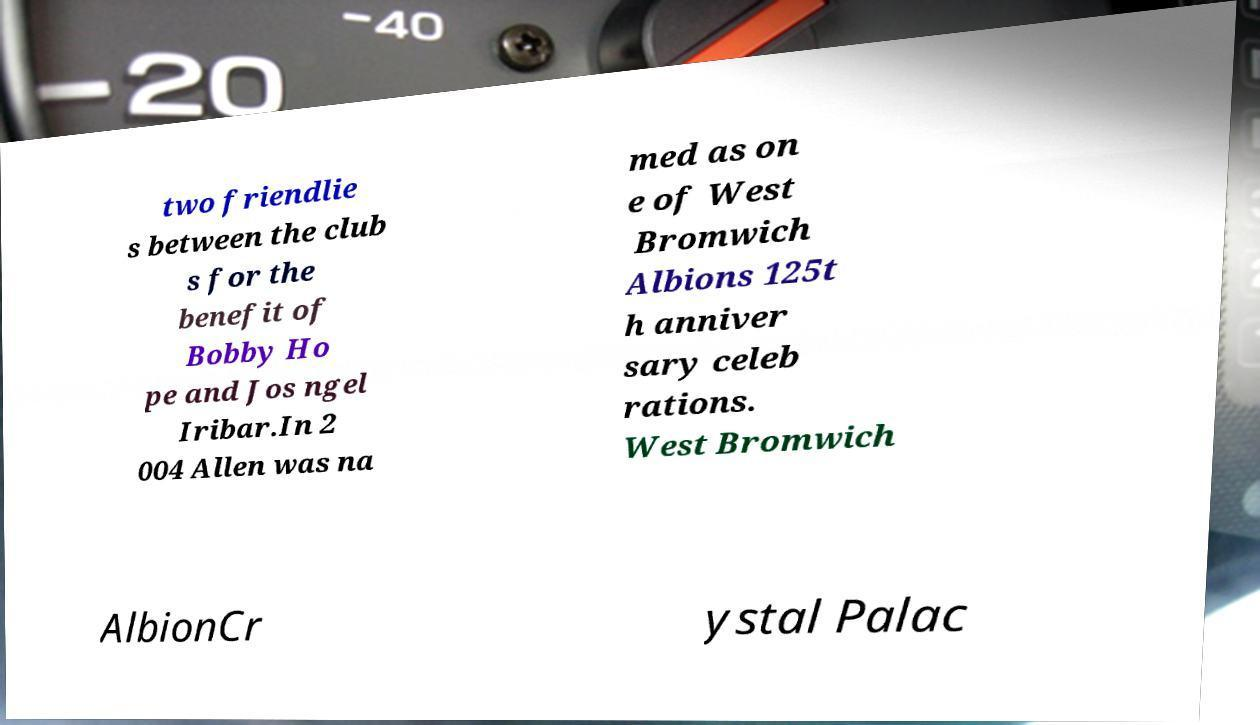What messages or text are displayed in this image? I need them in a readable, typed format. two friendlie s between the club s for the benefit of Bobby Ho pe and Jos ngel Iribar.In 2 004 Allen was na med as on e of West Bromwich Albions 125t h anniver sary celeb rations. West Bromwich AlbionCr ystal Palac 